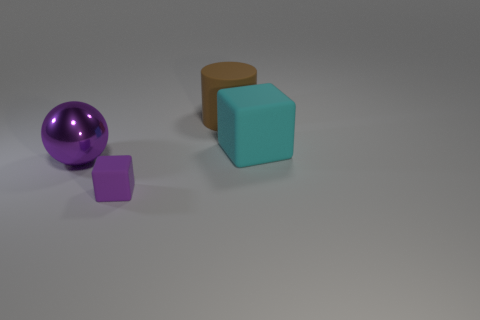Add 4 cyan rubber objects. How many objects exist? 8 Add 2 metal objects. How many metal objects are left? 3 Add 4 blue shiny things. How many blue shiny things exist? 4 Subtract 0 blue cubes. How many objects are left? 4 Subtract all tiny purple rubber cubes. Subtract all cylinders. How many objects are left? 2 